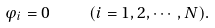Convert formula to latex. <formula><loc_0><loc_0><loc_500><loc_500>\varphi _ { i } = 0 \quad ( i = 1 , 2 , \cdots , N ) .</formula> 